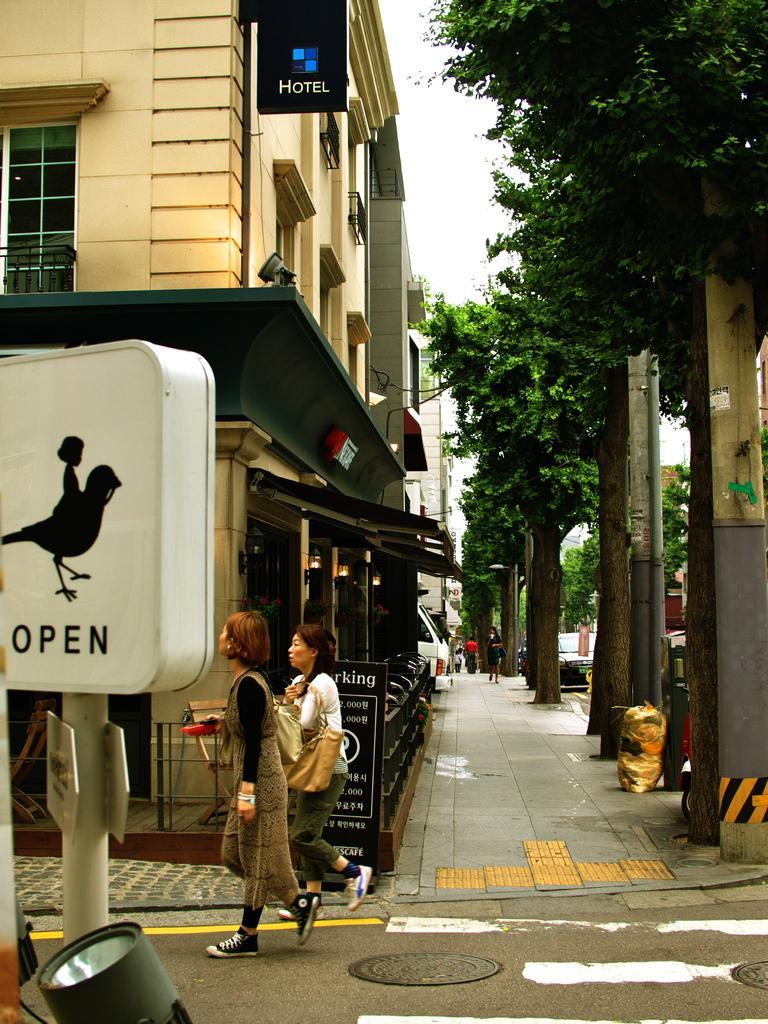Could you give a brief overview of what you see in this image? There is a lamp and pole on the left side of the image, there are buildings, stalls, people, trees, pole and sky in the background area. 